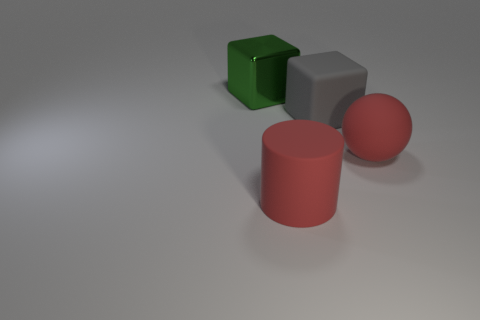What is the shape of the matte object that is behind the large red rubber object behind the large rubber object that is in front of the large red sphere?
Your response must be concise. Cube. Do the large gray thing and the metal thing have the same shape?
Make the answer very short. Yes. What shape is the red rubber thing behind the large red rubber thing in front of the rubber ball?
Provide a short and direct response. Sphere. Is there a big gray thing?
Your answer should be compact. Yes. There is a red thing right of the rubber thing that is in front of the red sphere; what number of rubber things are on the left side of it?
Offer a terse response. 2. There is a gray rubber thing; is it the same shape as the big rubber object that is right of the large gray matte cube?
Your response must be concise. No. Are there more big cylinders than small gray rubber blocks?
Your response must be concise. Yes. Do the big object left of the big red cylinder and the big gray thing have the same shape?
Your answer should be compact. Yes. Is the number of gray cubes that are behind the large red cylinder greater than the number of purple objects?
Your answer should be very brief. Yes. What color is the large matte ball that is to the right of the large red thing to the left of the large rubber sphere?
Provide a succinct answer. Red. 